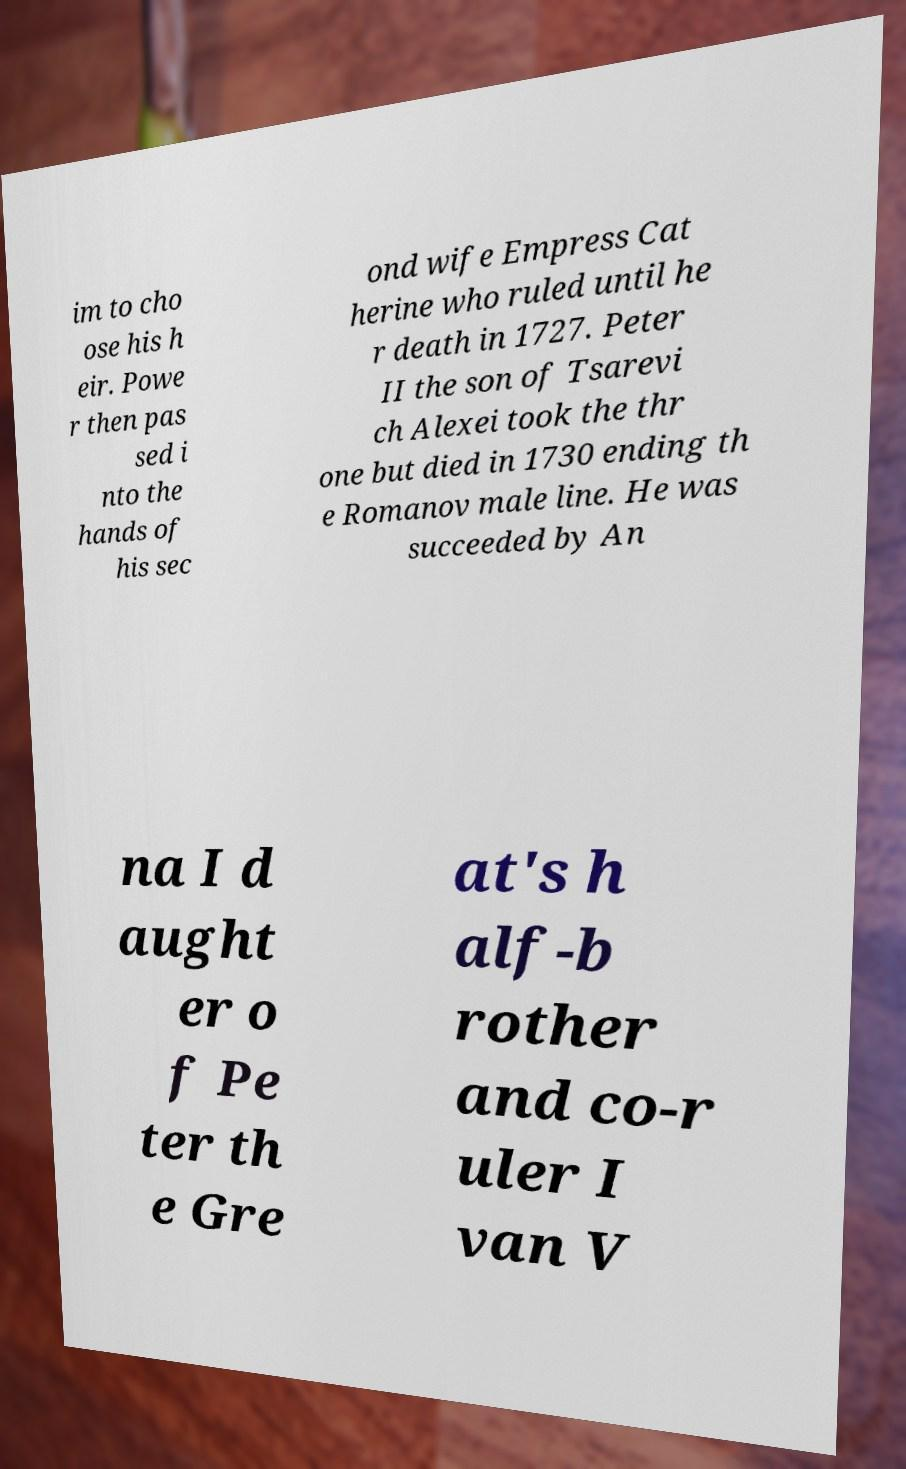There's text embedded in this image that I need extracted. Can you transcribe it verbatim? im to cho ose his h eir. Powe r then pas sed i nto the hands of his sec ond wife Empress Cat herine who ruled until he r death in 1727. Peter II the son of Tsarevi ch Alexei took the thr one but died in 1730 ending th e Romanov male line. He was succeeded by An na I d aught er o f Pe ter th e Gre at's h alf-b rother and co-r uler I van V 